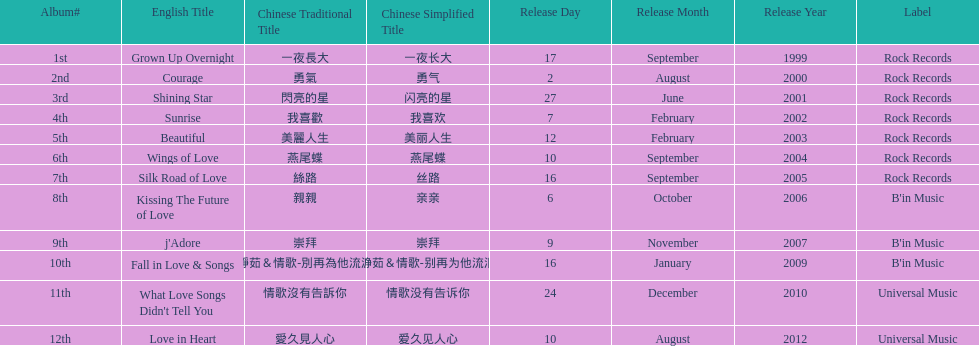Which was the only album to be released by b'in music in an even-numbered year? Kissing The Future of Love. 